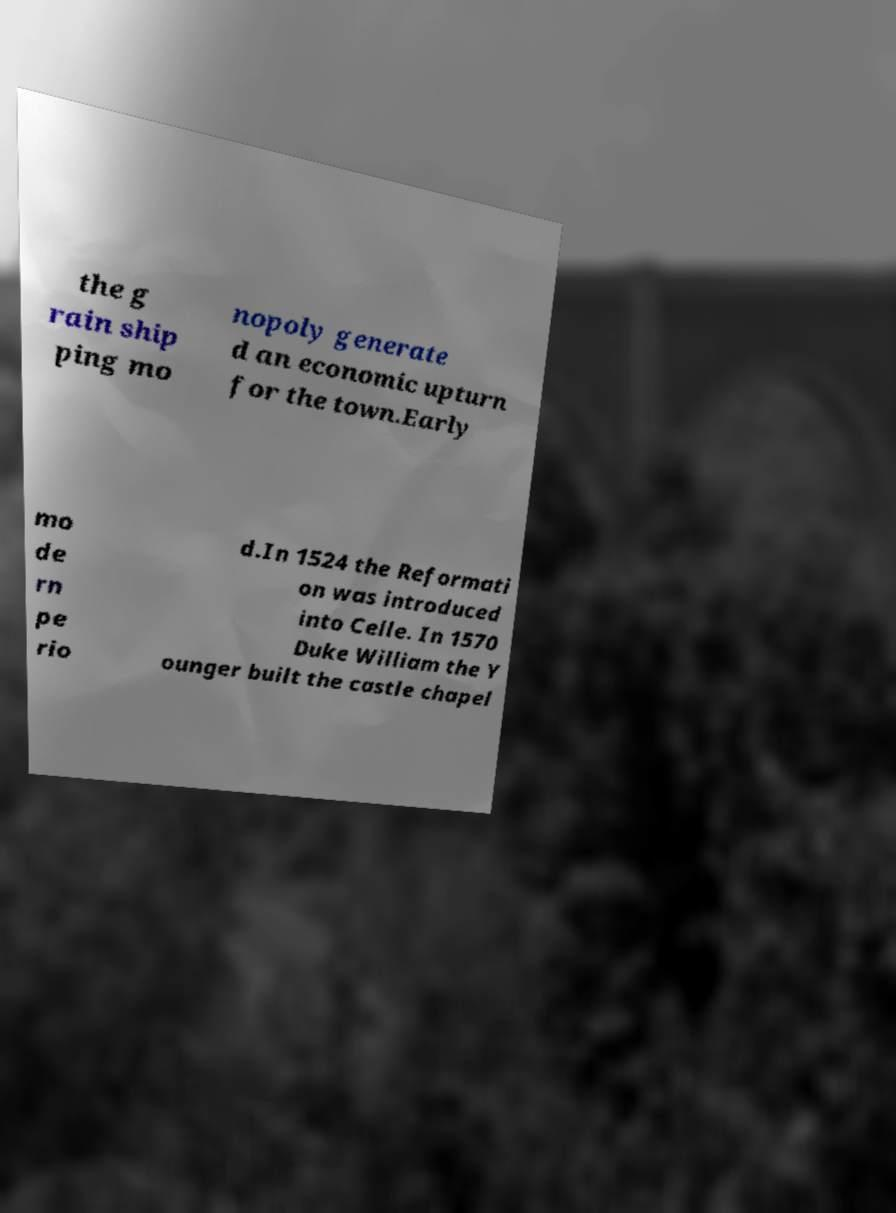I need the written content from this picture converted into text. Can you do that? the g rain ship ping mo nopoly generate d an economic upturn for the town.Early mo de rn pe rio d.In 1524 the Reformati on was introduced into Celle. In 1570 Duke William the Y ounger built the castle chapel 